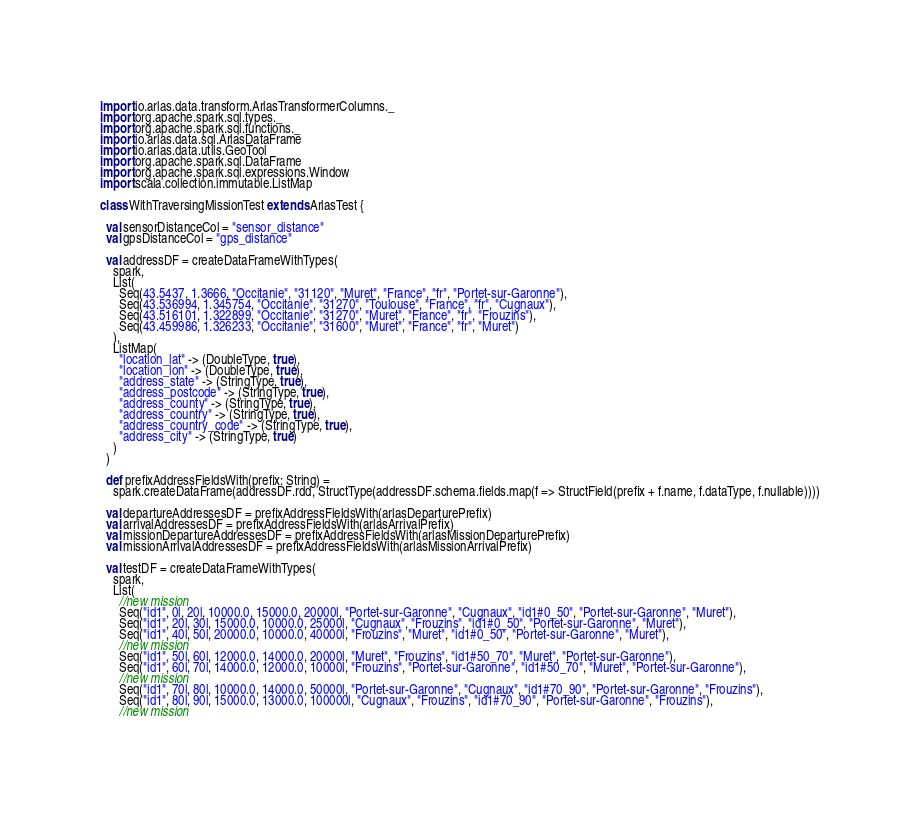Convert code to text. <code><loc_0><loc_0><loc_500><loc_500><_Scala_>import io.arlas.data.transform.ArlasTransformerColumns._
import org.apache.spark.sql.types._
import org.apache.spark.sql.functions._
import io.arlas.data.sql.ArlasDataFrame
import io.arlas.data.utils.GeoTool
import org.apache.spark.sql.DataFrame
import org.apache.spark.sql.expressions.Window
import scala.collection.immutable.ListMap

class WithTraversingMissionTest extends ArlasTest {

  val sensorDistanceCol = "sensor_distance"
  val gpsDistanceCol = "gps_distance"

  val addressDF = createDataFrameWithTypes(
    spark,
    List(
      Seq(43.5437, 1.3666, "Occitanie", "31120", "Muret", "France", "fr", "Portet-sur-Garonne"),
      Seq(43.536994, 1.345754, "Occitanie", "31270", "Toulouse", "France", "fr", "Cugnaux"),
      Seq(43.516101, 1.322899, "Occitanie", "31270", "Muret", "France", "fr", "Frouzins"),
      Seq(43.459986, 1.326233, "Occitanie", "31600", "Muret", "France", "fr", "Muret")
    ),
    ListMap(
      "location_lat" -> (DoubleType, true),
      "location_lon" -> (DoubleType, true),
      "address_state" -> (StringType, true),
      "address_postcode" -> (StringType, true),
      "address_county" -> (StringType, true),
      "address_country" -> (StringType, true),
      "address_country_code" -> (StringType, true),
      "address_city" -> (StringType, true)
    )
  )

  def prefixAddressFieldsWith(prefix: String) =
    spark.createDataFrame(addressDF.rdd, StructType(addressDF.schema.fields.map(f => StructField(prefix + f.name, f.dataType, f.nullable))))

  val departureAddressesDF = prefixAddressFieldsWith(arlasDeparturePrefix)
  val arrivalAddressesDF = prefixAddressFieldsWith(arlasArrivalPrefix)
  val missionDepartureAddressesDF = prefixAddressFieldsWith(arlasMissionDeparturePrefix)
  val missionArrivalAddressesDF = prefixAddressFieldsWith(arlasMissionArrivalPrefix)

  val testDF = createDataFrameWithTypes(
    spark,
    List(
      //new mission
      Seq("id1", 0l, 20l, 10000.0, 15000.0, 20000l, "Portet-sur-Garonne", "Cugnaux", "id1#0_50", "Portet-sur-Garonne", "Muret"),
      Seq("id1", 20l, 30l, 15000.0, 10000.0, 25000l, "Cugnaux", "Frouzins", "id1#0_50", "Portet-sur-Garonne", "Muret"),
      Seq("id1", 40l, 50l, 20000.0, 10000.0, 40000l, "Frouzins", "Muret", "id1#0_50", "Portet-sur-Garonne", "Muret"),
      //new mission
      Seq("id1", 50l, 60l, 12000.0, 14000.0, 20000l, "Muret", "Frouzins", "id1#50_70", "Muret", "Portet-sur-Garonne"),
      Seq("id1", 60l, 70l, 14000.0, 12000.0, 10000l, "Frouzins", "Portet-sur-Garonne", "id1#50_70", "Muret", "Portet-sur-Garonne"),
      //new mission
      Seq("id1", 70l, 80l, 10000.0, 14000.0, 50000l, "Portet-sur-Garonne", "Cugnaux", "id1#70_90", "Portet-sur-Garonne", "Frouzins"),
      Seq("id1", 80l, 90l, 15000.0, 13000.0, 100000l, "Cugnaux", "Frouzins", "id1#70_90", "Portet-sur-Garonne", "Frouzins"),
      //new mission</code> 